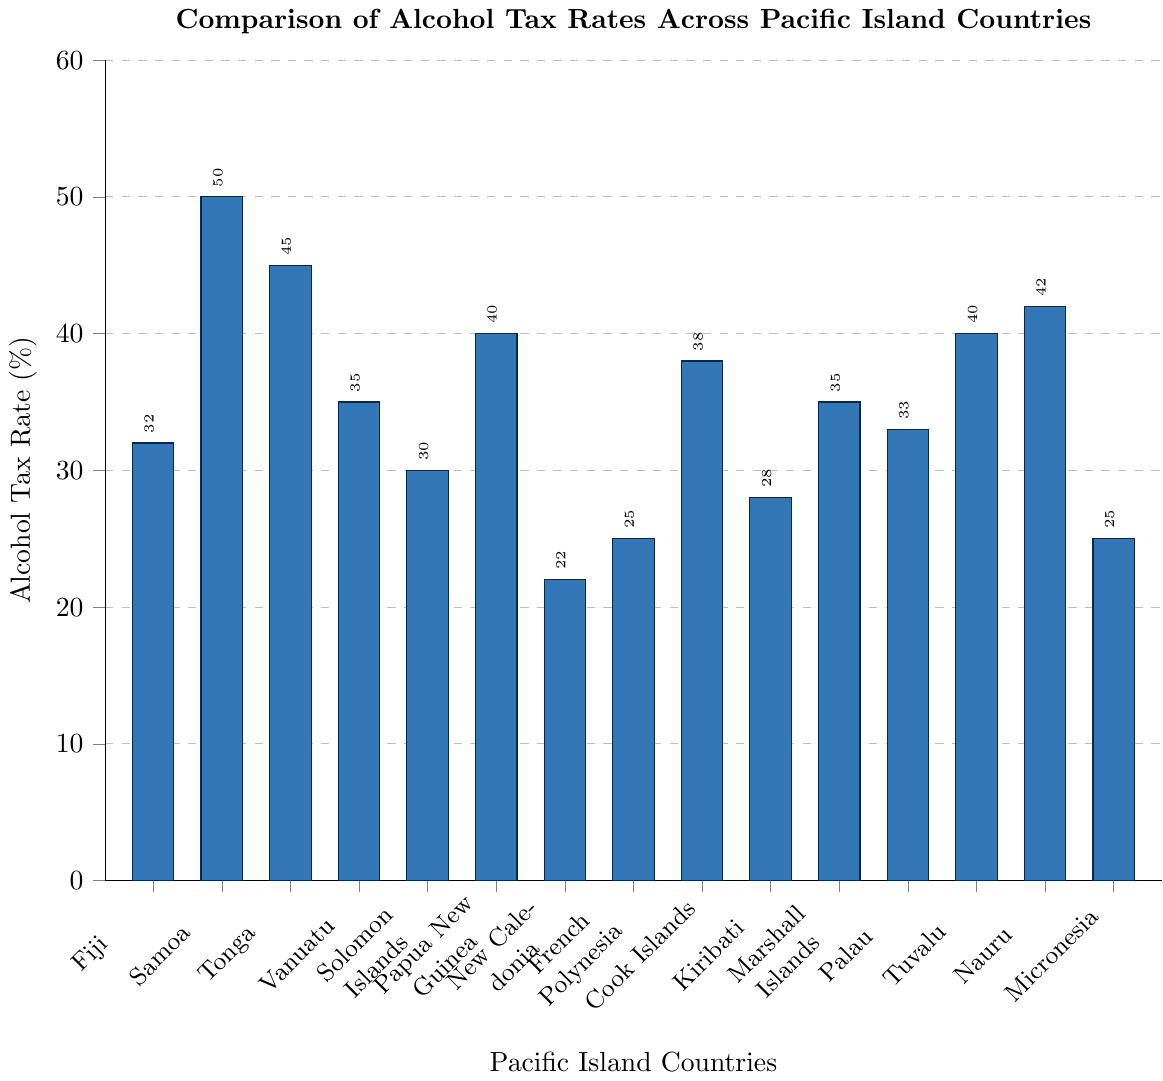Which country has the highest alcohol tax rate? To find the country with the highest alcohol tax rate, look at the top of the bar chart and identify the tallest bar, which represents the highest value.
Answer: Samoa Which country has a lower alcohol tax rate, Fiji or Palau? Compare the heights of the bars for Fiji and Palau. The bar for Fiji is at 32%, and the bar for Palau is at 33%. Therefore, Fiji has a lower rate.
Answer: Fiji What is the average alcohol tax rate across all the countries? Sum all the tax rates: 32 + 50 + 45 + 35 + 30 + 40 + 22 + 25 + 38 + 28 + 35 + 33 + 40 + 42 + 25 = 520. Then divide by the number of countries (15) to get the average: 520 / 15 ≈ 34.7
Answer: 34.7 By how much does Samoa’s tax rate exceed New Caledonia’s? Subtract New Caledonia's tax rate from Samoa's: 50 - 22 = 28
Answer: 28 What is the median alcohol tax rate? Arrange the rates in ascending order: 22, 25, 25, 28, 30, 32, 33, 35, 35, 38, 40, 40, 42, 45, 50. The middle value (8th in the list) is 35.
Answer: 35 Which countries have an alcohol tax rate greater than 40%? Identify the countries with bars higher than the 40% mark: Samoa, Tonga, Nauru.
Answer: Samoa, Tonga, Nauru What is the total alcohol tax rate of countries with rates less than 30%? Sum the rates for New Caledonia (22), French Polynesia (25), and Micronesia (25): 22 + 25 + 25 = 72
Answer: 72 How many countries have an alcohol tax rate between 30% and 40%? Count the number of bars with heights between 30% and 40%: Fiji (32), Vanuatu (35), Solomon Islands (30), Marshall Islands (35), Palau (33), Kiribati (28), Cook Islands (38). There are 6 countries.
Answer: 7 